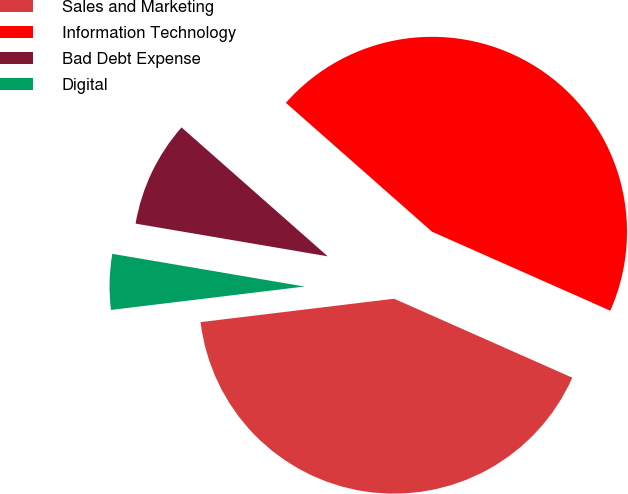Convert chart to OTSL. <chart><loc_0><loc_0><loc_500><loc_500><pie_chart><fcel>Sales and Marketing<fcel>Information Technology<fcel>Bad Debt Expense<fcel>Digital<nl><fcel>41.45%<fcel>45.14%<fcel>8.82%<fcel>4.6%<nl></chart> 